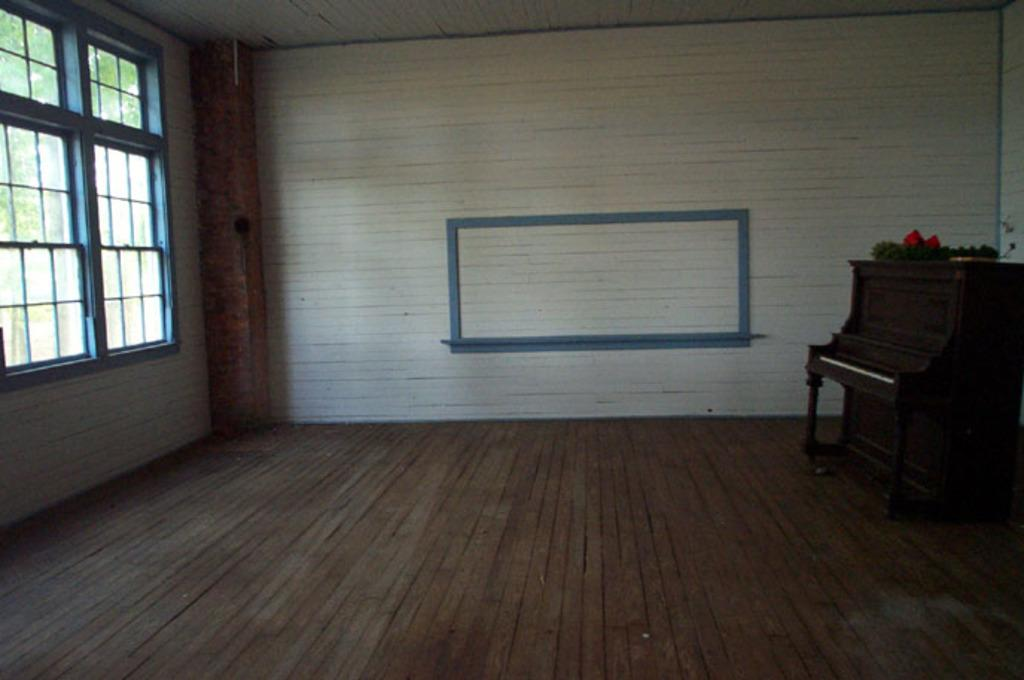What type of space is depicted in the image? There is a room in the image. What musical instrument can be seen in the room? A: There is a piano on the right side of the room. What feature allows natural light to enter the room? There is a window on the left side of the room. What type of hospital equipment can be seen near the piano in the image? There is no hospital equipment present in the image; it features a room with a piano and a window. Is there a guitar visible on the roof of the building in the image? There is no roof or guitar visible in the image; it only shows a room with a piano and a window. 